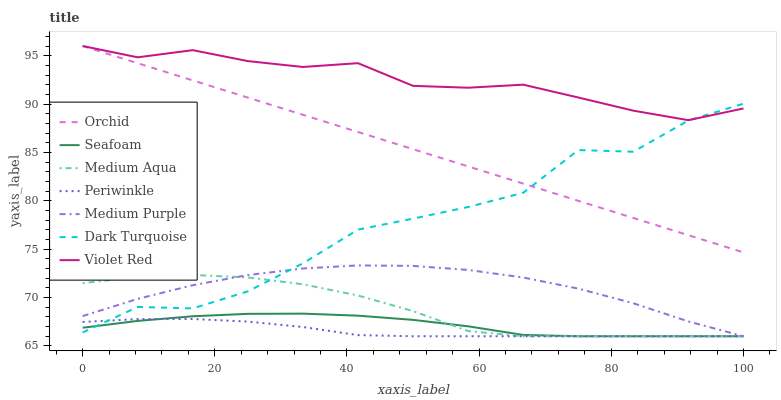Does Periwinkle have the minimum area under the curve?
Answer yes or no. Yes. Does Violet Red have the maximum area under the curve?
Answer yes or no. Yes. Does Dark Turquoise have the minimum area under the curve?
Answer yes or no. No. Does Dark Turquoise have the maximum area under the curve?
Answer yes or no. No. Is Orchid the smoothest?
Answer yes or no. Yes. Is Dark Turquoise the roughest?
Answer yes or no. Yes. Is Seafoam the smoothest?
Answer yes or no. No. Is Seafoam the roughest?
Answer yes or no. No. Does Seafoam have the lowest value?
Answer yes or no. Yes. Does Dark Turquoise have the lowest value?
Answer yes or no. No. Does Orchid have the highest value?
Answer yes or no. Yes. Does Dark Turquoise have the highest value?
Answer yes or no. No. Is Medium Purple less than Orchid?
Answer yes or no. Yes. Is Orchid greater than Seafoam?
Answer yes or no. Yes. Does Seafoam intersect Periwinkle?
Answer yes or no. Yes. Is Seafoam less than Periwinkle?
Answer yes or no. No. Is Seafoam greater than Periwinkle?
Answer yes or no. No. Does Medium Purple intersect Orchid?
Answer yes or no. No. 